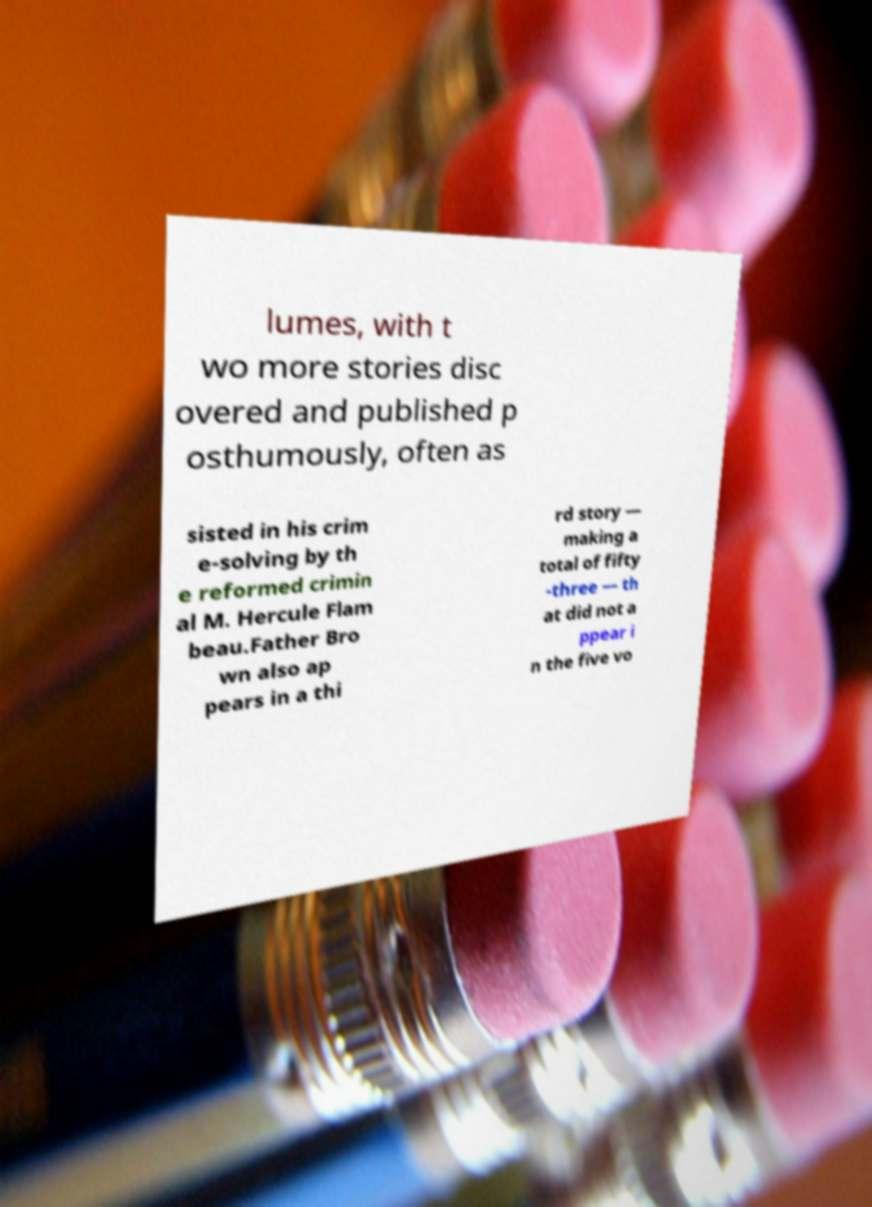Please identify and transcribe the text found in this image. lumes, with t wo more stories disc overed and published p osthumously, often as sisted in his crim e-solving by th e reformed crimin al M. Hercule Flam beau.Father Bro wn also ap pears in a thi rd story — making a total of fifty -three — th at did not a ppear i n the five vo 